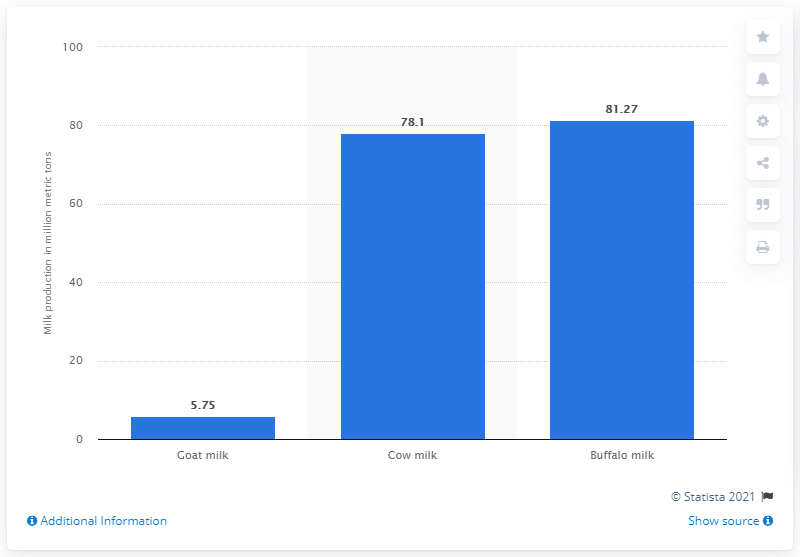Identify some key points in this picture. In 2017, a total of 81,270 metric tons of goat milk was produced in India. In the fiscal year 2017, approximately 81.27 million liters of cow milk was produced in India. 